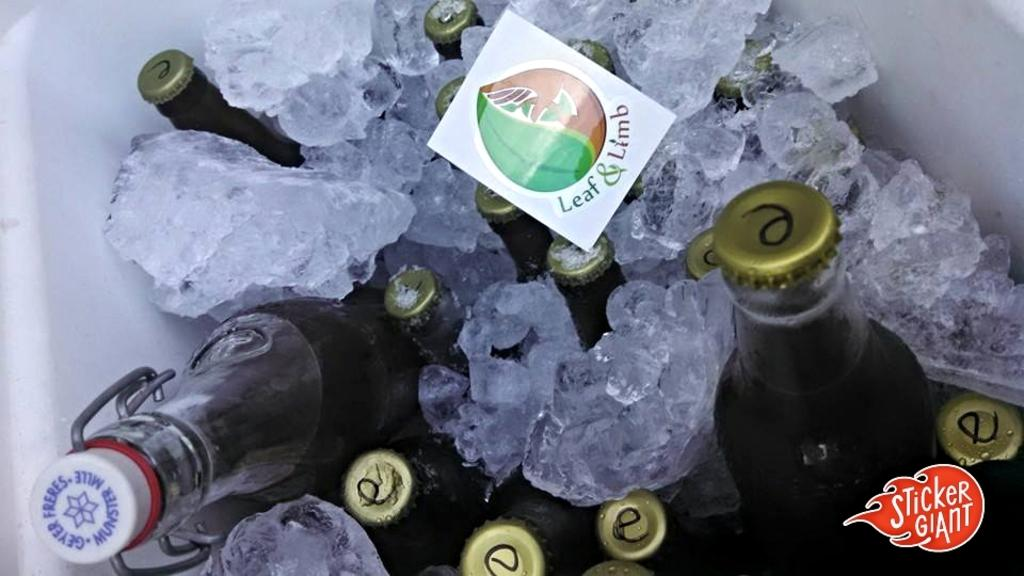<image>
Give a short and clear explanation of the subsequent image. cooler with bottles and ice and sticker on top for leaf & limb 